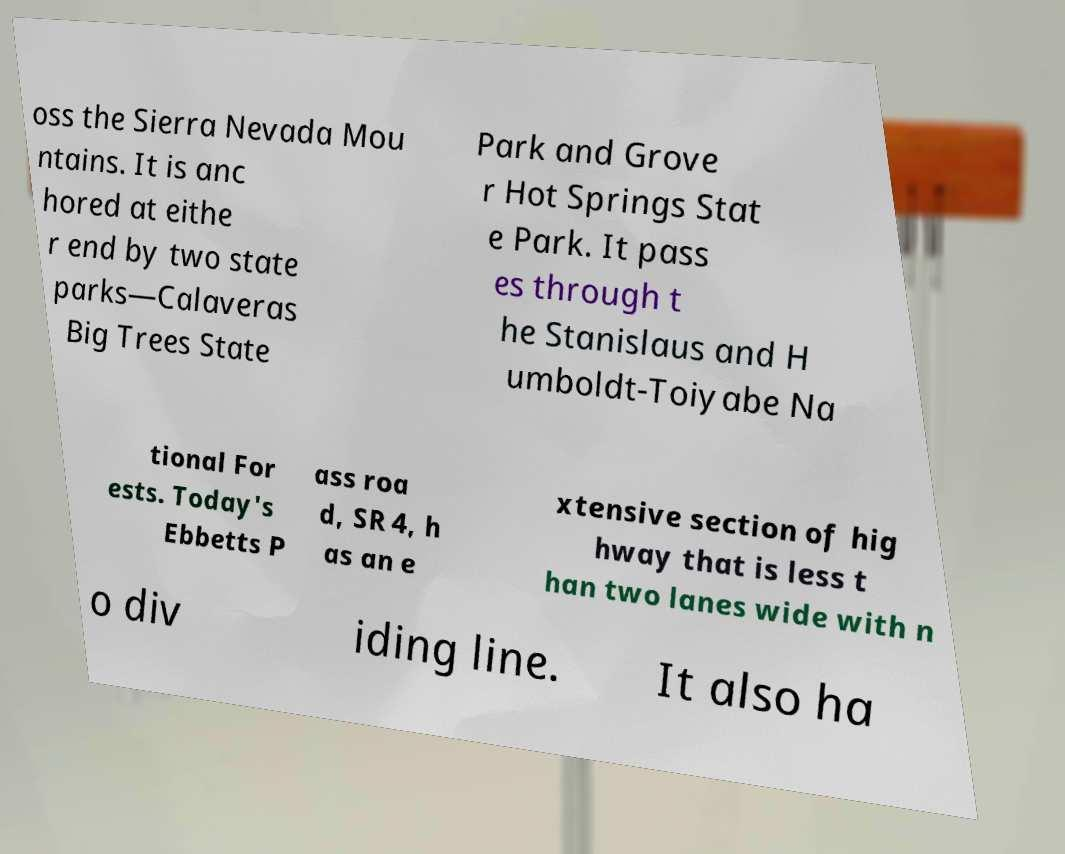For documentation purposes, I need the text within this image transcribed. Could you provide that? oss the Sierra Nevada Mou ntains. It is anc hored at eithe r end by two state parks—Calaveras Big Trees State Park and Grove r Hot Springs Stat e Park. It pass es through t he Stanislaus and H umboldt-Toiyabe Na tional For ests. Today's Ebbetts P ass roa d, SR 4, h as an e xtensive section of hig hway that is less t han two lanes wide with n o div iding line. It also ha 